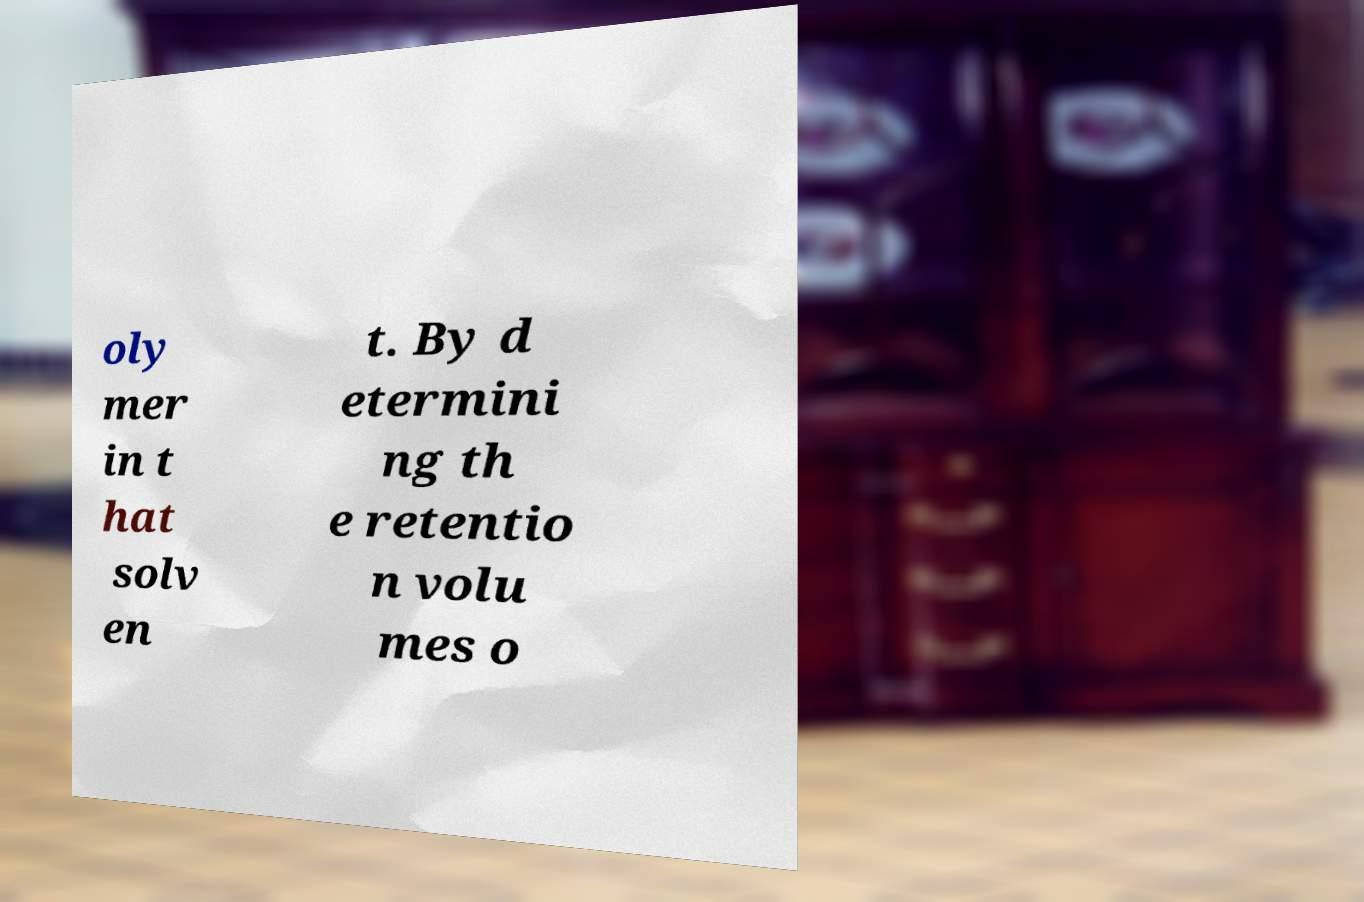Could you assist in decoding the text presented in this image and type it out clearly? oly mer in t hat solv en t. By d etermini ng th e retentio n volu mes o 